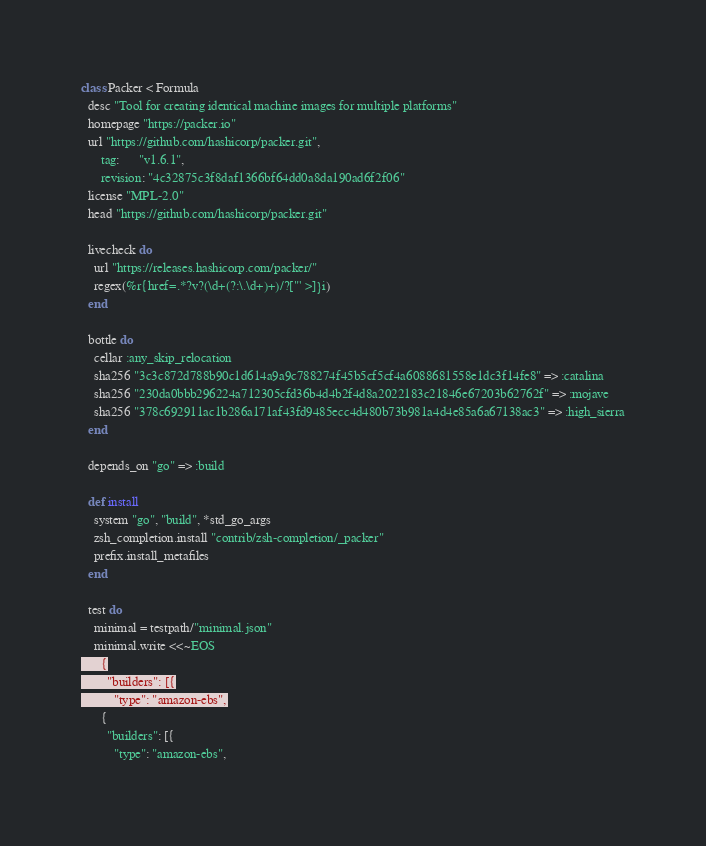<code> <loc_0><loc_0><loc_500><loc_500><_Ruby_>class Packer < Formula
  desc "Tool for creating identical machine images for multiple platforms"
  homepage "https://packer.io"
  url "https://github.com/hashicorp/packer.git",
      tag:      "v1.6.1",
      revision: "4c32875c3f8daf1366bf64dd0a8da190ad6f2f06"
  license "MPL-2.0"
  head "https://github.com/hashicorp/packer.git"

  livecheck do
    url "https://releases.hashicorp.com/packer/"
    regex(%r{href=.*?v?(\d+(?:\.\d+)+)/?["' >]}i)
  end

  bottle do
    cellar :any_skip_relocation
    sha256 "3c3c872d788b90c1d614a9a9c788274f45b5cf5cf4a6088681558e1dc3f14fe8" => :catalina
    sha256 "230da0bbb296224a712305cfd36b4d4b2f4d8a2022183c21846e67203b62762f" => :mojave
    sha256 "378c692911ac1b286a171af43fd9485ecc4d480b73b981a4d4e85a6a67138ac3" => :high_sierra
  end

  depends_on "go" => :build

  def install
    system "go", "build", *std_go_args
    zsh_completion.install "contrib/zsh-completion/_packer"
    prefix.install_metafiles
  end

  test do
    minimal = testpath/"minimal.json"
    minimal.write <<~EOS
      {
        "builders": [{
          "type": "amazon-ebs",</code> 